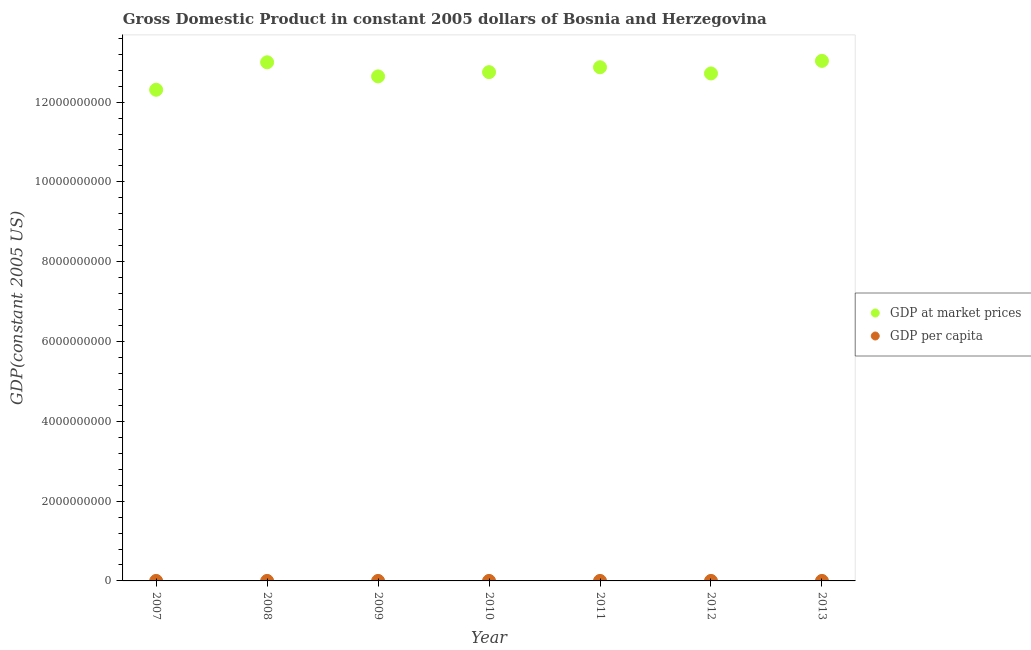How many different coloured dotlines are there?
Give a very brief answer. 2. What is the gdp per capita in 2009?
Offer a terse response. 3294.87. Across all years, what is the maximum gdp at market prices?
Your response must be concise. 1.30e+1. Across all years, what is the minimum gdp at market prices?
Offer a very short reply. 1.23e+1. In which year was the gdp per capita maximum?
Offer a very short reply. 2013. What is the total gdp per capita in the graph?
Make the answer very short. 2.33e+04. What is the difference between the gdp at market prices in 2008 and that in 2013?
Provide a short and direct response. -3.52e+07. What is the difference between the gdp per capita in 2012 and the gdp at market prices in 2008?
Offer a very short reply. -1.30e+1. What is the average gdp per capita per year?
Provide a short and direct response. 3328.58. In the year 2013, what is the difference between the gdp per capita and gdp at market prices?
Your response must be concise. -1.30e+1. What is the ratio of the gdp per capita in 2010 to that in 2012?
Keep it short and to the point. 1. Is the gdp at market prices in 2009 less than that in 2012?
Provide a succinct answer. Yes. What is the difference between the highest and the second highest gdp at market prices?
Offer a very short reply. 3.52e+07. What is the difference between the highest and the lowest gdp at market prices?
Offer a very short reply. 7.24e+08. In how many years, is the gdp per capita greater than the average gdp per capita taken over all years?
Keep it short and to the point. 3. Is the sum of the gdp at market prices in 2008 and 2009 greater than the maximum gdp per capita across all years?
Provide a succinct answer. Yes. What is the difference between two consecutive major ticks on the Y-axis?
Offer a terse response. 2.00e+09. Are the values on the major ticks of Y-axis written in scientific E-notation?
Your answer should be very brief. No. Does the graph contain grids?
Your answer should be compact. No. How many legend labels are there?
Your response must be concise. 2. What is the title of the graph?
Ensure brevity in your answer.  Gross Domestic Product in constant 2005 dollars of Bosnia and Herzegovina. Does "Boys" appear as one of the legend labels in the graph?
Your answer should be very brief. No. What is the label or title of the X-axis?
Give a very brief answer. Year. What is the label or title of the Y-axis?
Ensure brevity in your answer.  GDP(constant 2005 US). What is the GDP(constant 2005 US) in GDP at market prices in 2007?
Provide a succinct answer. 1.23e+1. What is the GDP(constant 2005 US) of GDP per capita in 2007?
Give a very brief answer. 3205.3. What is the GDP(constant 2005 US) of GDP at market prices in 2008?
Your response must be concise. 1.30e+1. What is the GDP(constant 2005 US) in GDP per capita in 2008?
Provide a short and direct response. 3385.18. What is the GDP(constant 2005 US) in GDP at market prices in 2009?
Make the answer very short. 1.26e+1. What is the GDP(constant 2005 US) in GDP per capita in 2009?
Your answer should be compact. 3294.87. What is the GDP(constant 2005 US) of GDP at market prices in 2010?
Provide a succinct answer. 1.28e+1. What is the GDP(constant 2005 US) in GDP per capita in 2010?
Give a very brief answer. 3324.76. What is the GDP(constant 2005 US) of GDP at market prices in 2011?
Make the answer very short. 1.29e+1. What is the GDP(constant 2005 US) of GDP per capita in 2011?
Offer a very short reply. 3359.18. What is the GDP(constant 2005 US) of GDP at market prices in 2012?
Your answer should be very brief. 1.27e+1. What is the GDP(constant 2005 US) of GDP per capita in 2012?
Give a very brief answer. 3322.01. What is the GDP(constant 2005 US) in GDP at market prices in 2013?
Offer a very short reply. 1.30e+1. What is the GDP(constant 2005 US) of GDP per capita in 2013?
Provide a succinct answer. 3408.75. Across all years, what is the maximum GDP(constant 2005 US) of GDP at market prices?
Keep it short and to the point. 1.30e+1. Across all years, what is the maximum GDP(constant 2005 US) in GDP per capita?
Give a very brief answer. 3408.75. Across all years, what is the minimum GDP(constant 2005 US) of GDP at market prices?
Offer a very short reply. 1.23e+1. Across all years, what is the minimum GDP(constant 2005 US) of GDP per capita?
Provide a short and direct response. 3205.3. What is the total GDP(constant 2005 US) of GDP at market prices in the graph?
Provide a short and direct response. 8.93e+1. What is the total GDP(constant 2005 US) in GDP per capita in the graph?
Your answer should be very brief. 2.33e+04. What is the difference between the GDP(constant 2005 US) of GDP at market prices in 2007 and that in 2008?
Your answer should be compact. -6.89e+08. What is the difference between the GDP(constant 2005 US) in GDP per capita in 2007 and that in 2008?
Provide a short and direct response. -179.88. What is the difference between the GDP(constant 2005 US) in GDP at market prices in 2007 and that in 2009?
Your answer should be very brief. -3.35e+08. What is the difference between the GDP(constant 2005 US) of GDP per capita in 2007 and that in 2009?
Provide a succinct answer. -89.57. What is the difference between the GDP(constant 2005 US) in GDP at market prices in 2007 and that in 2010?
Make the answer very short. -4.42e+08. What is the difference between the GDP(constant 2005 US) in GDP per capita in 2007 and that in 2010?
Your response must be concise. -119.46. What is the difference between the GDP(constant 2005 US) in GDP at market prices in 2007 and that in 2011?
Offer a terse response. -5.64e+08. What is the difference between the GDP(constant 2005 US) in GDP per capita in 2007 and that in 2011?
Your response must be concise. -153.88. What is the difference between the GDP(constant 2005 US) in GDP at market prices in 2007 and that in 2012?
Make the answer very short. -4.08e+08. What is the difference between the GDP(constant 2005 US) in GDP per capita in 2007 and that in 2012?
Provide a short and direct response. -116.71. What is the difference between the GDP(constant 2005 US) of GDP at market prices in 2007 and that in 2013?
Make the answer very short. -7.24e+08. What is the difference between the GDP(constant 2005 US) in GDP per capita in 2007 and that in 2013?
Give a very brief answer. -203.45. What is the difference between the GDP(constant 2005 US) of GDP at market prices in 2008 and that in 2009?
Provide a succinct answer. 3.53e+08. What is the difference between the GDP(constant 2005 US) of GDP per capita in 2008 and that in 2009?
Your response must be concise. 90.31. What is the difference between the GDP(constant 2005 US) of GDP at market prices in 2008 and that in 2010?
Your answer should be compact. 2.47e+08. What is the difference between the GDP(constant 2005 US) of GDP per capita in 2008 and that in 2010?
Provide a short and direct response. 60.42. What is the difference between the GDP(constant 2005 US) in GDP at market prices in 2008 and that in 2011?
Keep it short and to the point. 1.25e+08. What is the difference between the GDP(constant 2005 US) in GDP per capita in 2008 and that in 2011?
Make the answer very short. 26. What is the difference between the GDP(constant 2005 US) in GDP at market prices in 2008 and that in 2012?
Keep it short and to the point. 2.80e+08. What is the difference between the GDP(constant 2005 US) of GDP per capita in 2008 and that in 2012?
Offer a terse response. 63.17. What is the difference between the GDP(constant 2005 US) of GDP at market prices in 2008 and that in 2013?
Offer a terse response. -3.52e+07. What is the difference between the GDP(constant 2005 US) in GDP per capita in 2008 and that in 2013?
Ensure brevity in your answer.  -23.57. What is the difference between the GDP(constant 2005 US) of GDP at market prices in 2009 and that in 2010?
Give a very brief answer. -1.06e+08. What is the difference between the GDP(constant 2005 US) in GDP per capita in 2009 and that in 2010?
Keep it short and to the point. -29.89. What is the difference between the GDP(constant 2005 US) in GDP at market prices in 2009 and that in 2011?
Your response must be concise. -2.29e+08. What is the difference between the GDP(constant 2005 US) in GDP per capita in 2009 and that in 2011?
Keep it short and to the point. -64.31. What is the difference between the GDP(constant 2005 US) of GDP at market prices in 2009 and that in 2012?
Your answer should be compact. -7.32e+07. What is the difference between the GDP(constant 2005 US) in GDP per capita in 2009 and that in 2012?
Provide a succinct answer. -27.14. What is the difference between the GDP(constant 2005 US) of GDP at market prices in 2009 and that in 2013?
Ensure brevity in your answer.  -3.89e+08. What is the difference between the GDP(constant 2005 US) of GDP per capita in 2009 and that in 2013?
Give a very brief answer. -113.88. What is the difference between the GDP(constant 2005 US) of GDP at market prices in 2010 and that in 2011?
Make the answer very short. -1.22e+08. What is the difference between the GDP(constant 2005 US) in GDP per capita in 2010 and that in 2011?
Provide a short and direct response. -34.43. What is the difference between the GDP(constant 2005 US) of GDP at market prices in 2010 and that in 2012?
Your response must be concise. 3.32e+07. What is the difference between the GDP(constant 2005 US) in GDP per capita in 2010 and that in 2012?
Your answer should be compact. 2.75. What is the difference between the GDP(constant 2005 US) in GDP at market prices in 2010 and that in 2013?
Give a very brief answer. -2.82e+08. What is the difference between the GDP(constant 2005 US) of GDP per capita in 2010 and that in 2013?
Provide a short and direct response. -83.99. What is the difference between the GDP(constant 2005 US) in GDP at market prices in 2011 and that in 2012?
Offer a very short reply. 1.55e+08. What is the difference between the GDP(constant 2005 US) of GDP per capita in 2011 and that in 2012?
Offer a terse response. 37.17. What is the difference between the GDP(constant 2005 US) of GDP at market prices in 2011 and that in 2013?
Your response must be concise. -1.60e+08. What is the difference between the GDP(constant 2005 US) in GDP per capita in 2011 and that in 2013?
Keep it short and to the point. -49.57. What is the difference between the GDP(constant 2005 US) in GDP at market prices in 2012 and that in 2013?
Your response must be concise. -3.15e+08. What is the difference between the GDP(constant 2005 US) of GDP per capita in 2012 and that in 2013?
Offer a terse response. -86.74. What is the difference between the GDP(constant 2005 US) in GDP at market prices in 2007 and the GDP(constant 2005 US) in GDP per capita in 2008?
Ensure brevity in your answer.  1.23e+1. What is the difference between the GDP(constant 2005 US) of GDP at market prices in 2007 and the GDP(constant 2005 US) of GDP per capita in 2009?
Keep it short and to the point. 1.23e+1. What is the difference between the GDP(constant 2005 US) in GDP at market prices in 2007 and the GDP(constant 2005 US) in GDP per capita in 2010?
Keep it short and to the point. 1.23e+1. What is the difference between the GDP(constant 2005 US) in GDP at market prices in 2007 and the GDP(constant 2005 US) in GDP per capita in 2011?
Provide a short and direct response. 1.23e+1. What is the difference between the GDP(constant 2005 US) of GDP at market prices in 2007 and the GDP(constant 2005 US) of GDP per capita in 2012?
Your answer should be very brief. 1.23e+1. What is the difference between the GDP(constant 2005 US) of GDP at market prices in 2007 and the GDP(constant 2005 US) of GDP per capita in 2013?
Your answer should be compact. 1.23e+1. What is the difference between the GDP(constant 2005 US) in GDP at market prices in 2008 and the GDP(constant 2005 US) in GDP per capita in 2009?
Offer a very short reply. 1.30e+1. What is the difference between the GDP(constant 2005 US) in GDP at market prices in 2008 and the GDP(constant 2005 US) in GDP per capita in 2010?
Keep it short and to the point. 1.30e+1. What is the difference between the GDP(constant 2005 US) in GDP at market prices in 2008 and the GDP(constant 2005 US) in GDP per capita in 2011?
Make the answer very short. 1.30e+1. What is the difference between the GDP(constant 2005 US) in GDP at market prices in 2008 and the GDP(constant 2005 US) in GDP per capita in 2012?
Provide a succinct answer. 1.30e+1. What is the difference between the GDP(constant 2005 US) of GDP at market prices in 2008 and the GDP(constant 2005 US) of GDP per capita in 2013?
Keep it short and to the point. 1.30e+1. What is the difference between the GDP(constant 2005 US) of GDP at market prices in 2009 and the GDP(constant 2005 US) of GDP per capita in 2010?
Your response must be concise. 1.26e+1. What is the difference between the GDP(constant 2005 US) in GDP at market prices in 2009 and the GDP(constant 2005 US) in GDP per capita in 2011?
Make the answer very short. 1.26e+1. What is the difference between the GDP(constant 2005 US) in GDP at market prices in 2009 and the GDP(constant 2005 US) in GDP per capita in 2012?
Give a very brief answer. 1.26e+1. What is the difference between the GDP(constant 2005 US) of GDP at market prices in 2009 and the GDP(constant 2005 US) of GDP per capita in 2013?
Provide a succinct answer. 1.26e+1. What is the difference between the GDP(constant 2005 US) in GDP at market prices in 2010 and the GDP(constant 2005 US) in GDP per capita in 2011?
Your answer should be compact. 1.28e+1. What is the difference between the GDP(constant 2005 US) in GDP at market prices in 2010 and the GDP(constant 2005 US) in GDP per capita in 2012?
Your answer should be very brief. 1.28e+1. What is the difference between the GDP(constant 2005 US) of GDP at market prices in 2010 and the GDP(constant 2005 US) of GDP per capita in 2013?
Offer a terse response. 1.28e+1. What is the difference between the GDP(constant 2005 US) of GDP at market prices in 2011 and the GDP(constant 2005 US) of GDP per capita in 2012?
Offer a terse response. 1.29e+1. What is the difference between the GDP(constant 2005 US) in GDP at market prices in 2011 and the GDP(constant 2005 US) in GDP per capita in 2013?
Ensure brevity in your answer.  1.29e+1. What is the difference between the GDP(constant 2005 US) of GDP at market prices in 2012 and the GDP(constant 2005 US) of GDP per capita in 2013?
Make the answer very short. 1.27e+1. What is the average GDP(constant 2005 US) in GDP at market prices per year?
Your answer should be very brief. 1.28e+1. What is the average GDP(constant 2005 US) of GDP per capita per year?
Your answer should be compact. 3328.58. In the year 2007, what is the difference between the GDP(constant 2005 US) of GDP at market prices and GDP(constant 2005 US) of GDP per capita?
Offer a terse response. 1.23e+1. In the year 2008, what is the difference between the GDP(constant 2005 US) of GDP at market prices and GDP(constant 2005 US) of GDP per capita?
Offer a terse response. 1.30e+1. In the year 2009, what is the difference between the GDP(constant 2005 US) in GDP at market prices and GDP(constant 2005 US) in GDP per capita?
Provide a short and direct response. 1.26e+1. In the year 2010, what is the difference between the GDP(constant 2005 US) of GDP at market prices and GDP(constant 2005 US) of GDP per capita?
Make the answer very short. 1.28e+1. In the year 2011, what is the difference between the GDP(constant 2005 US) in GDP at market prices and GDP(constant 2005 US) in GDP per capita?
Offer a very short reply. 1.29e+1. In the year 2012, what is the difference between the GDP(constant 2005 US) of GDP at market prices and GDP(constant 2005 US) of GDP per capita?
Your answer should be very brief. 1.27e+1. In the year 2013, what is the difference between the GDP(constant 2005 US) of GDP at market prices and GDP(constant 2005 US) of GDP per capita?
Keep it short and to the point. 1.30e+1. What is the ratio of the GDP(constant 2005 US) in GDP at market prices in 2007 to that in 2008?
Your answer should be compact. 0.95. What is the ratio of the GDP(constant 2005 US) in GDP per capita in 2007 to that in 2008?
Give a very brief answer. 0.95. What is the ratio of the GDP(constant 2005 US) of GDP at market prices in 2007 to that in 2009?
Provide a short and direct response. 0.97. What is the ratio of the GDP(constant 2005 US) in GDP per capita in 2007 to that in 2009?
Your answer should be very brief. 0.97. What is the ratio of the GDP(constant 2005 US) of GDP at market prices in 2007 to that in 2010?
Offer a terse response. 0.97. What is the ratio of the GDP(constant 2005 US) in GDP per capita in 2007 to that in 2010?
Make the answer very short. 0.96. What is the ratio of the GDP(constant 2005 US) of GDP at market prices in 2007 to that in 2011?
Your answer should be very brief. 0.96. What is the ratio of the GDP(constant 2005 US) in GDP per capita in 2007 to that in 2011?
Keep it short and to the point. 0.95. What is the ratio of the GDP(constant 2005 US) in GDP at market prices in 2007 to that in 2012?
Offer a very short reply. 0.97. What is the ratio of the GDP(constant 2005 US) of GDP per capita in 2007 to that in 2012?
Give a very brief answer. 0.96. What is the ratio of the GDP(constant 2005 US) of GDP at market prices in 2007 to that in 2013?
Your answer should be compact. 0.94. What is the ratio of the GDP(constant 2005 US) in GDP per capita in 2007 to that in 2013?
Make the answer very short. 0.94. What is the ratio of the GDP(constant 2005 US) of GDP at market prices in 2008 to that in 2009?
Provide a succinct answer. 1.03. What is the ratio of the GDP(constant 2005 US) of GDP per capita in 2008 to that in 2009?
Your answer should be very brief. 1.03. What is the ratio of the GDP(constant 2005 US) in GDP at market prices in 2008 to that in 2010?
Give a very brief answer. 1.02. What is the ratio of the GDP(constant 2005 US) in GDP per capita in 2008 to that in 2010?
Provide a succinct answer. 1.02. What is the ratio of the GDP(constant 2005 US) of GDP at market prices in 2008 to that in 2011?
Ensure brevity in your answer.  1.01. What is the ratio of the GDP(constant 2005 US) in GDP per capita in 2008 to that in 2011?
Provide a succinct answer. 1.01. What is the ratio of the GDP(constant 2005 US) in GDP at market prices in 2008 to that in 2012?
Provide a short and direct response. 1.02. What is the ratio of the GDP(constant 2005 US) in GDP per capita in 2008 to that in 2012?
Provide a succinct answer. 1.02. What is the ratio of the GDP(constant 2005 US) in GDP at market prices in 2008 to that in 2013?
Keep it short and to the point. 1. What is the ratio of the GDP(constant 2005 US) of GDP at market prices in 2009 to that in 2010?
Your answer should be compact. 0.99. What is the ratio of the GDP(constant 2005 US) in GDP per capita in 2009 to that in 2010?
Offer a terse response. 0.99. What is the ratio of the GDP(constant 2005 US) in GDP at market prices in 2009 to that in 2011?
Provide a succinct answer. 0.98. What is the ratio of the GDP(constant 2005 US) in GDP per capita in 2009 to that in 2011?
Your answer should be very brief. 0.98. What is the ratio of the GDP(constant 2005 US) of GDP at market prices in 2009 to that in 2013?
Your answer should be very brief. 0.97. What is the ratio of the GDP(constant 2005 US) in GDP per capita in 2009 to that in 2013?
Give a very brief answer. 0.97. What is the ratio of the GDP(constant 2005 US) in GDP per capita in 2010 to that in 2011?
Your answer should be very brief. 0.99. What is the ratio of the GDP(constant 2005 US) in GDP at market prices in 2010 to that in 2012?
Keep it short and to the point. 1. What is the ratio of the GDP(constant 2005 US) of GDP per capita in 2010 to that in 2012?
Your response must be concise. 1. What is the ratio of the GDP(constant 2005 US) of GDP at market prices in 2010 to that in 2013?
Ensure brevity in your answer.  0.98. What is the ratio of the GDP(constant 2005 US) of GDP per capita in 2010 to that in 2013?
Provide a succinct answer. 0.98. What is the ratio of the GDP(constant 2005 US) of GDP at market prices in 2011 to that in 2012?
Ensure brevity in your answer.  1.01. What is the ratio of the GDP(constant 2005 US) in GDP per capita in 2011 to that in 2012?
Give a very brief answer. 1.01. What is the ratio of the GDP(constant 2005 US) of GDP per capita in 2011 to that in 2013?
Give a very brief answer. 0.99. What is the ratio of the GDP(constant 2005 US) in GDP at market prices in 2012 to that in 2013?
Make the answer very short. 0.98. What is the ratio of the GDP(constant 2005 US) in GDP per capita in 2012 to that in 2013?
Your answer should be very brief. 0.97. What is the difference between the highest and the second highest GDP(constant 2005 US) of GDP at market prices?
Your answer should be compact. 3.52e+07. What is the difference between the highest and the second highest GDP(constant 2005 US) in GDP per capita?
Offer a terse response. 23.57. What is the difference between the highest and the lowest GDP(constant 2005 US) of GDP at market prices?
Offer a very short reply. 7.24e+08. What is the difference between the highest and the lowest GDP(constant 2005 US) of GDP per capita?
Your answer should be very brief. 203.45. 